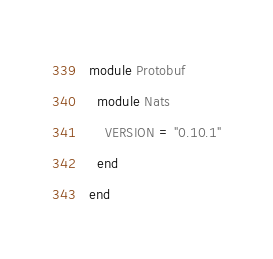<code> <loc_0><loc_0><loc_500><loc_500><_Ruby_>module Protobuf
  module Nats
    VERSION = "0.10.1"
  end
end
</code> 